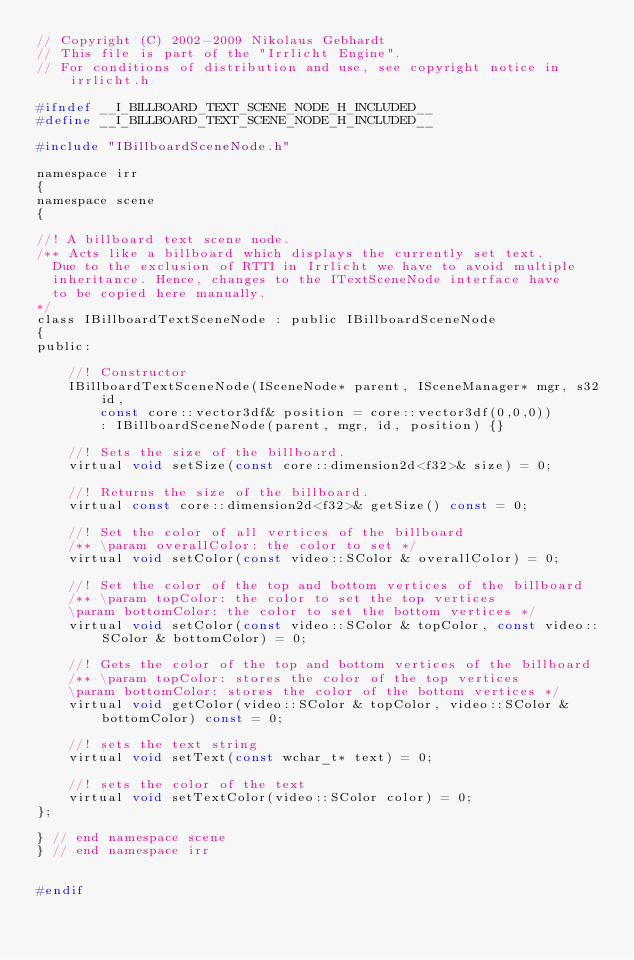<code> <loc_0><loc_0><loc_500><loc_500><_C_>// Copyright (C) 2002-2009 Nikolaus Gebhardt
// This file is part of the "Irrlicht Engine".
// For conditions of distribution and use, see copyright notice in irrlicht.h

#ifndef __I_BILLBOARD_TEXT_SCENE_NODE_H_INCLUDED__
#define __I_BILLBOARD_TEXT_SCENE_NODE_H_INCLUDED__

#include "IBillboardSceneNode.h"

namespace irr
{
namespace scene
{

//! A billboard text scene node.
/** Acts like a billboard which displays the currently set text.
  Due to the exclusion of RTTI in Irrlicht we have to avoid multiple
  inheritance. Hence, changes to the ITextSceneNode interface have
  to be copied here manually.
*/
class IBillboardTextSceneNode : public IBillboardSceneNode
{
public:

	//! Constructor
	IBillboardTextSceneNode(ISceneNode* parent, ISceneManager* mgr, s32 id,
		const core::vector3df& position = core::vector3df(0,0,0))
		: IBillboardSceneNode(parent, mgr, id, position) {}

	//! Sets the size of the billboard.
	virtual void setSize(const core::dimension2d<f32>& size) = 0;

	//! Returns the size of the billboard.
	virtual const core::dimension2d<f32>& getSize() const = 0;

	//! Set the color of all vertices of the billboard
	/** \param overallColor: the color to set */
	virtual void setColor(const video::SColor & overallColor) = 0;

	//! Set the color of the top and bottom vertices of the billboard
	/** \param topColor: the color to set the top vertices
	\param bottomColor: the color to set the bottom vertices */
	virtual void setColor(const video::SColor & topColor, const video::SColor & bottomColor) = 0;

	//! Gets the color of the top and bottom vertices of the billboard
	/** \param topColor: stores the color of the top vertices
	\param bottomColor: stores the color of the bottom vertices */
	virtual void getColor(video::SColor & topColor, video::SColor & bottomColor) const = 0;

	//! sets the text string
	virtual void setText(const wchar_t* text) = 0;

	//! sets the color of the text
	virtual void setTextColor(video::SColor color) = 0;
};

} // end namespace scene
} // end namespace irr


#endif

</code> 